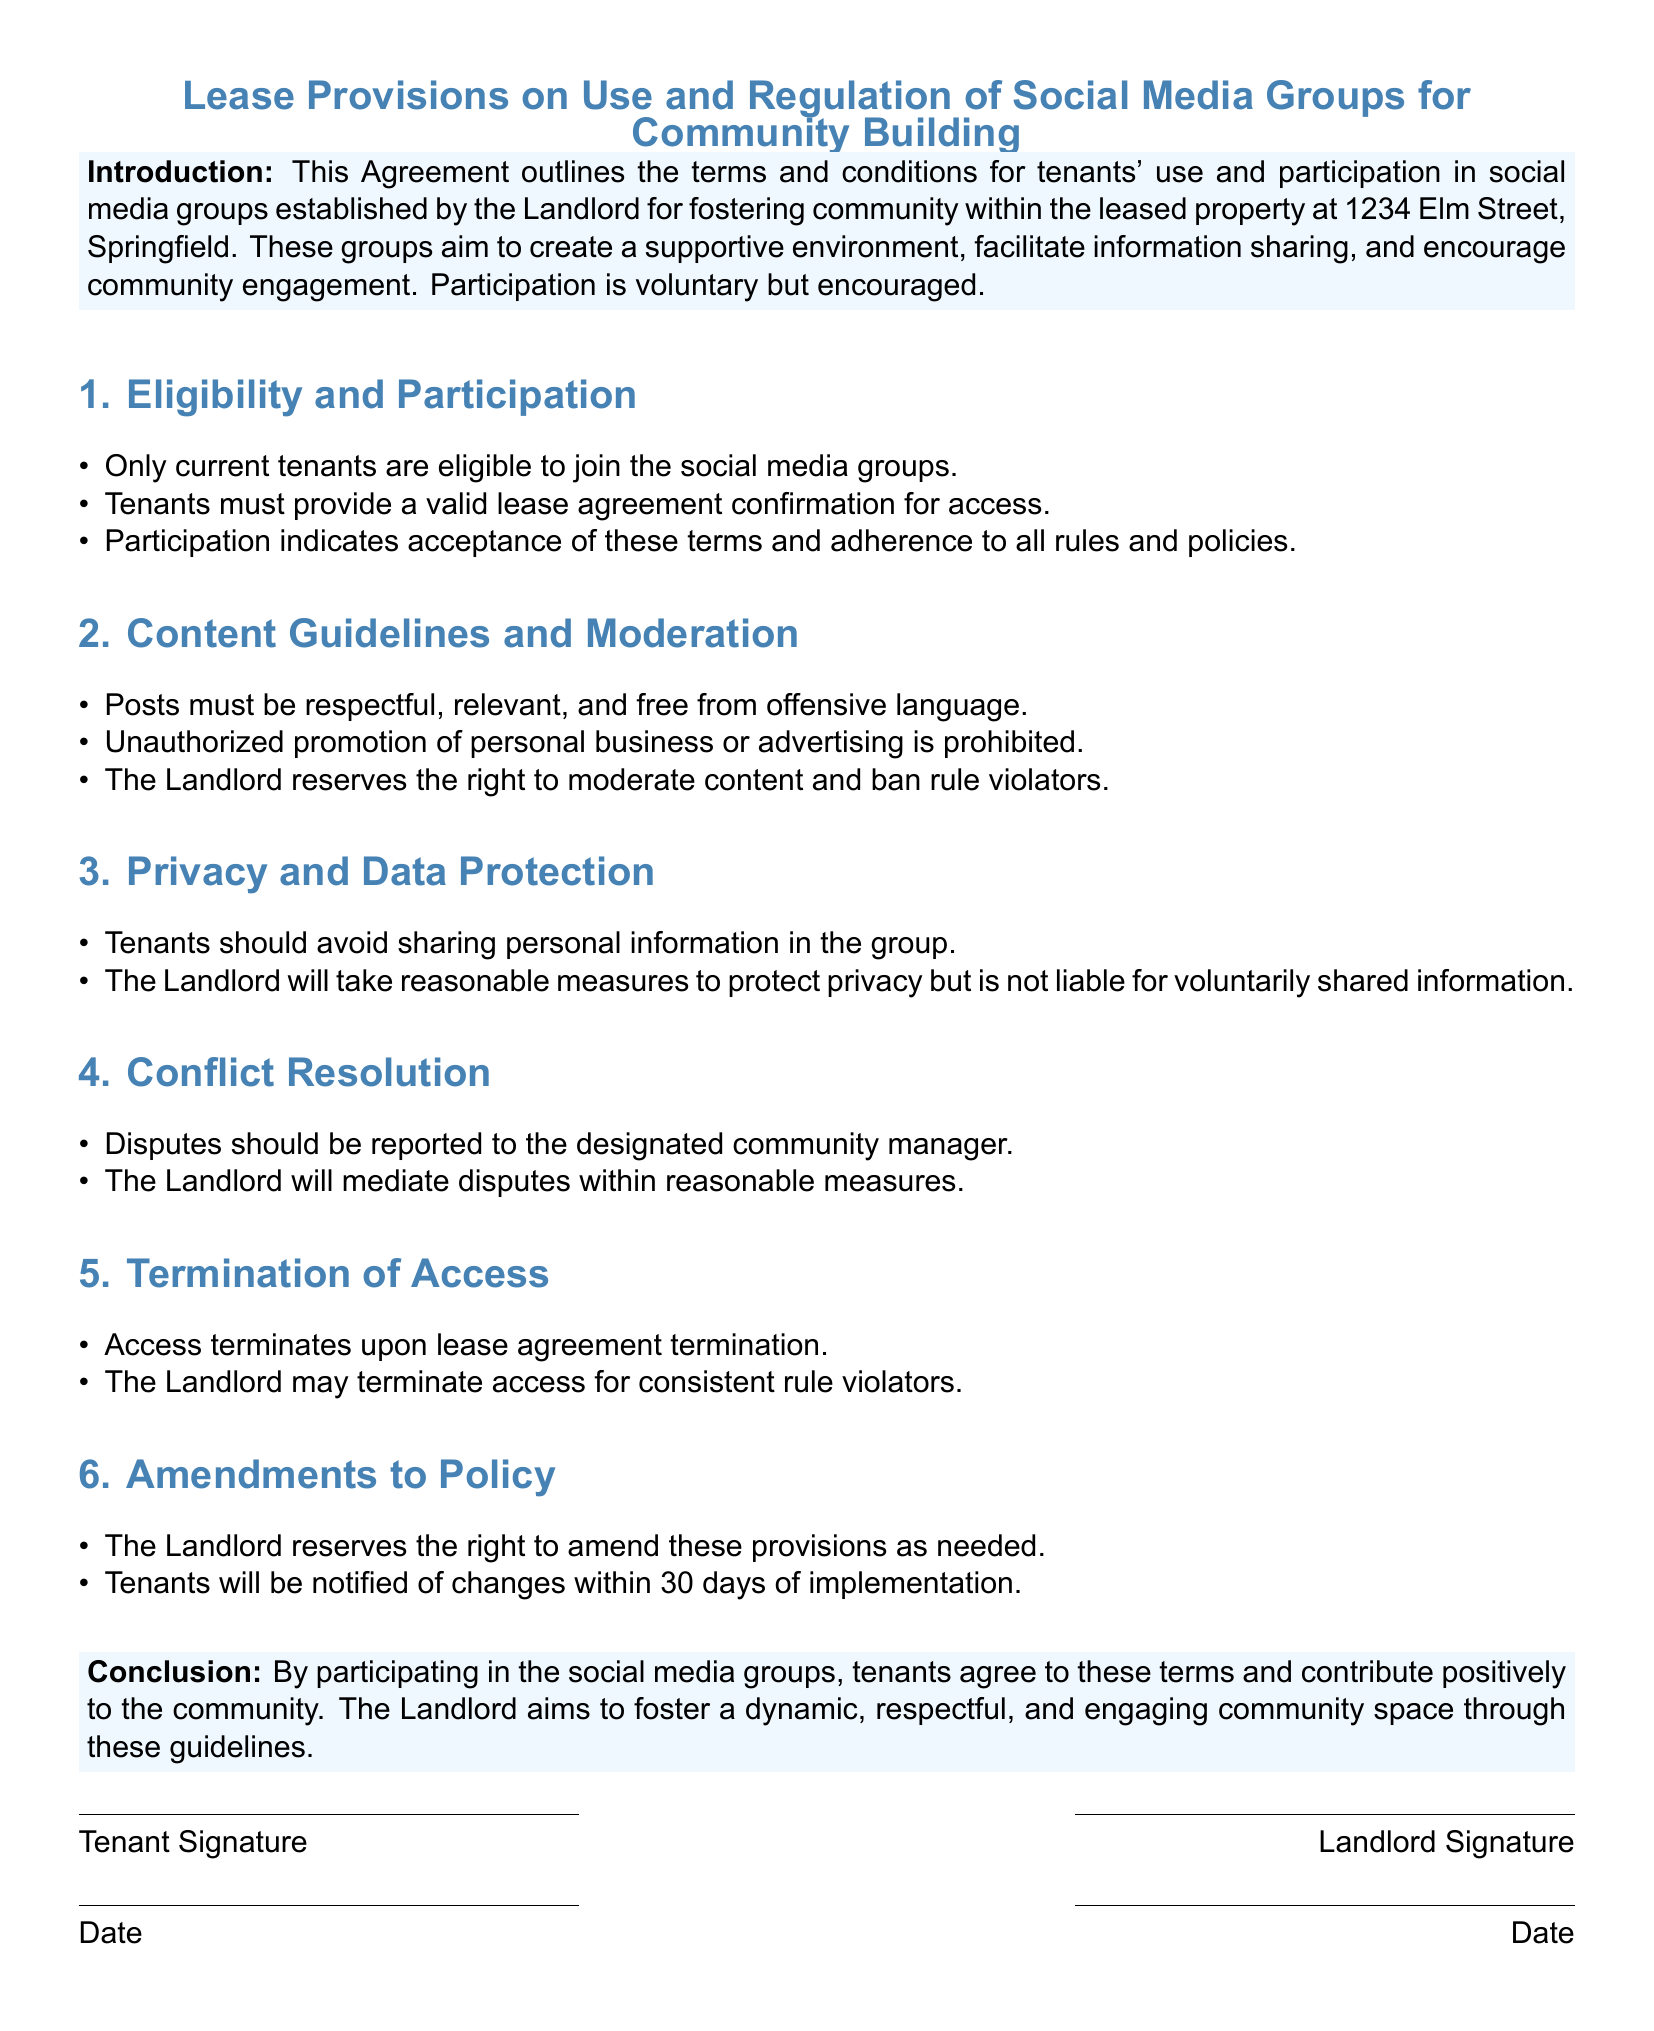What is the address of the property mentioned in the document? The address is explicitly stated for the leased property, which is 1234 Elm Street, Springfield.
Answer: 1234 Elm Street, Springfield Who reserves the right to moderate content in the social media groups? The document specifies that the Landlord has the authority to moderate content.
Answer: The Landlord What must tenants provide for access to social media groups? Tenants are required to provide a valid lease agreement confirmation for access, as indicated in the provisions.
Answer: Valid lease agreement confirmation What is the consequence for consistent rule violators regarding social media access? According to the document, access may be terminated for those who consistently violate rules.
Answer: Termination of access How long do tenants have to be notified of any changes to the provisions? The document states that tenants will be notified of amendments within 30 days of implementation.
Answer: 30 days What type of information should tenants avoid sharing in the group? The content guidelines explicitly mention that tenants should avoid sharing personal information in the group.
Answer: Personal information Who should disputes be reported to according to the document? The designated community manager is specified as the person to report disputes to in the provisions.
Answer: Designated community manager Is participation in the social media groups mandatory? The introduction clarifies that participation is voluntary but encouraged for tenants.
Answer: Voluntary What is the overall aim of the social media groups as stated in the document? The introduction outlines that the groups aim to foster community, facilitate information sharing, and encourage engagement.
Answer: Foster community 